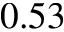<formula> <loc_0><loc_0><loc_500><loc_500>0 . 5 3</formula> 